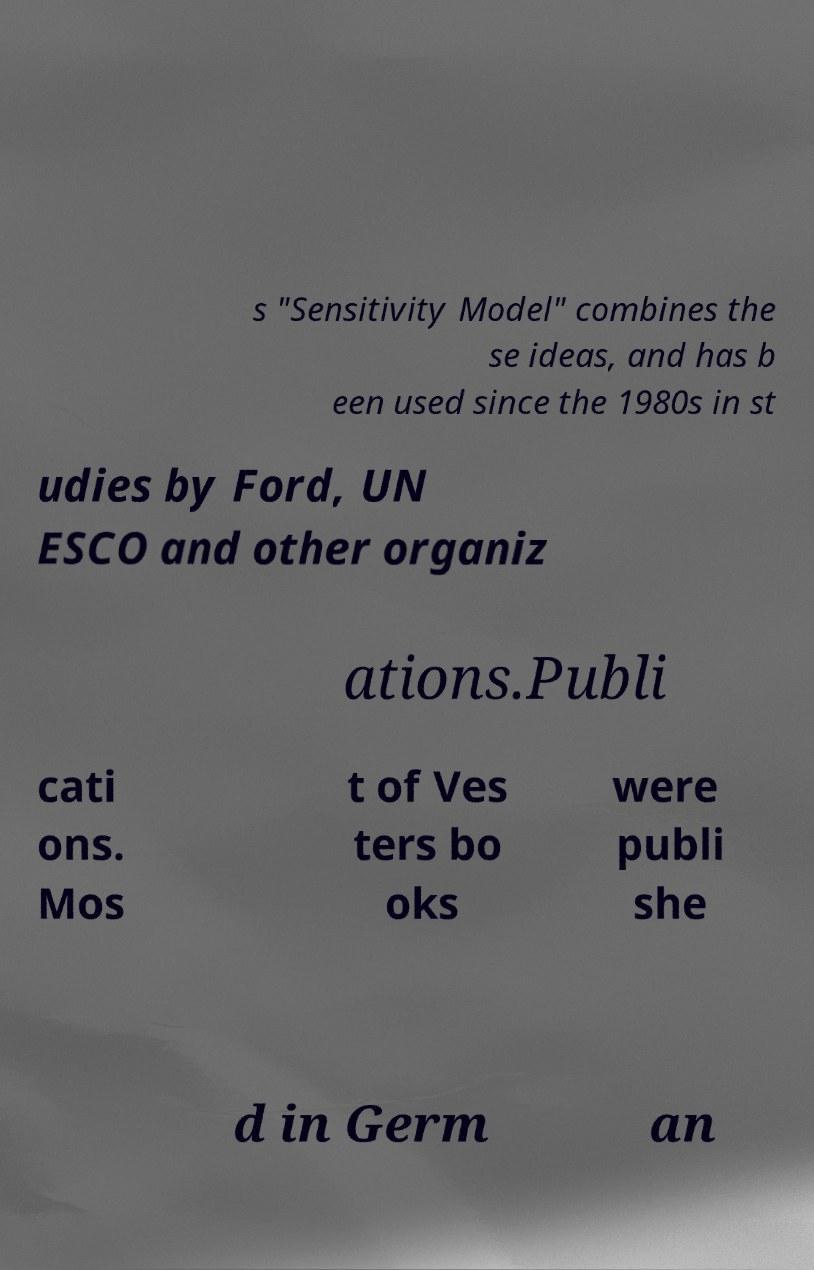For documentation purposes, I need the text within this image transcribed. Could you provide that? s "Sensitivity Model" combines the se ideas, and has b een used since the 1980s in st udies by Ford, UN ESCO and other organiz ations.Publi cati ons. Mos t of Ves ters bo oks were publi she d in Germ an 